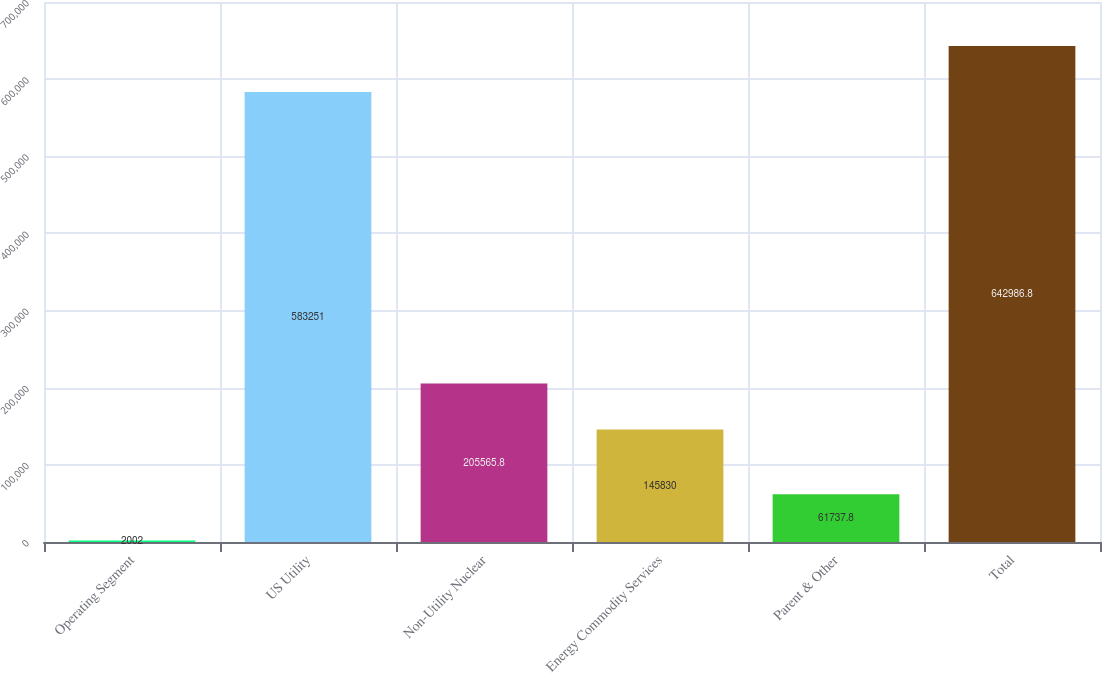<chart> <loc_0><loc_0><loc_500><loc_500><bar_chart><fcel>Operating Segment<fcel>US Utility<fcel>Non-Utility Nuclear<fcel>Energy Commodity Services<fcel>Parent & Other<fcel>Total<nl><fcel>2002<fcel>583251<fcel>205566<fcel>145830<fcel>61737.8<fcel>642987<nl></chart> 